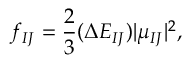<formula> <loc_0><loc_0><loc_500><loc_500>f _ { I J } = \frac { 2 } { 3 } ( \Delta E _ { I J } ) | \mu _ { I J } | ^ { 2 } ,</formula> 